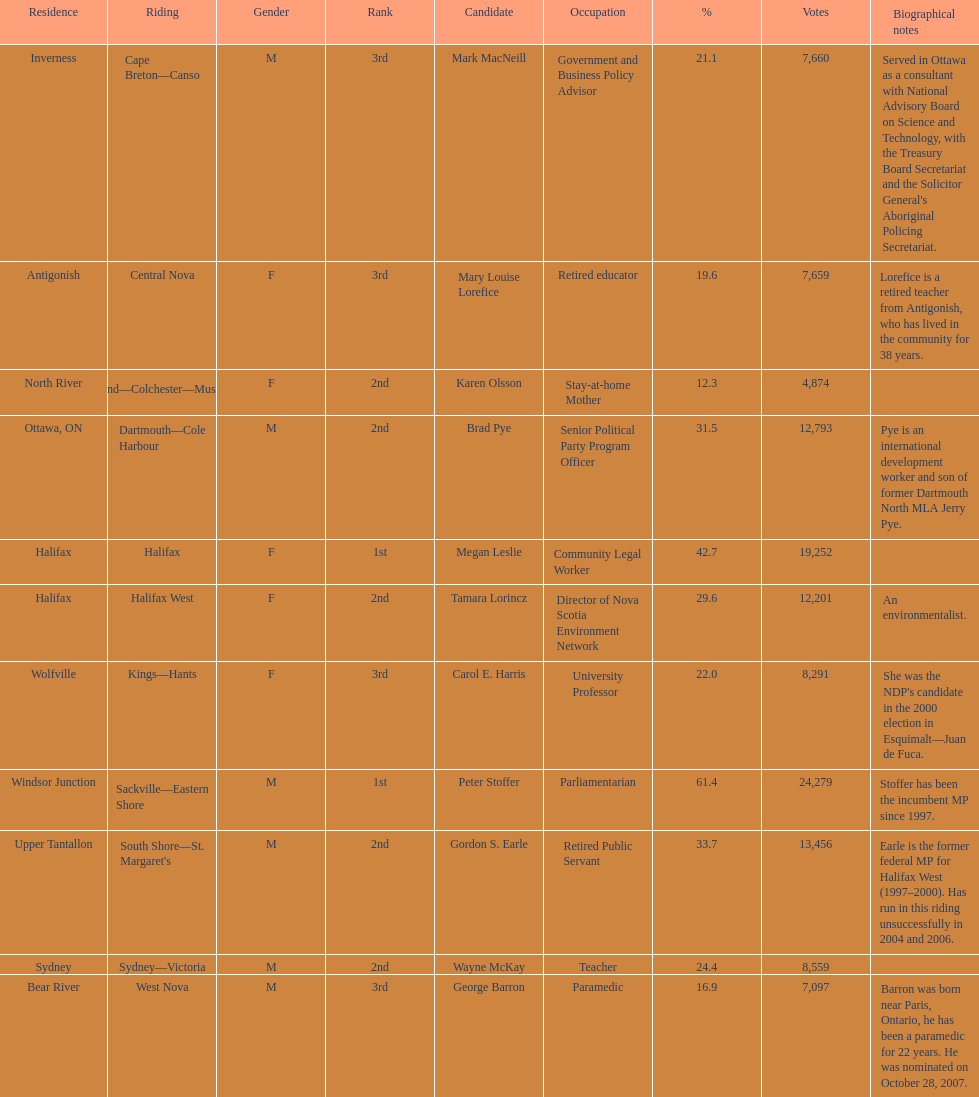Who received the least amount of votes? Karen Olsson. 